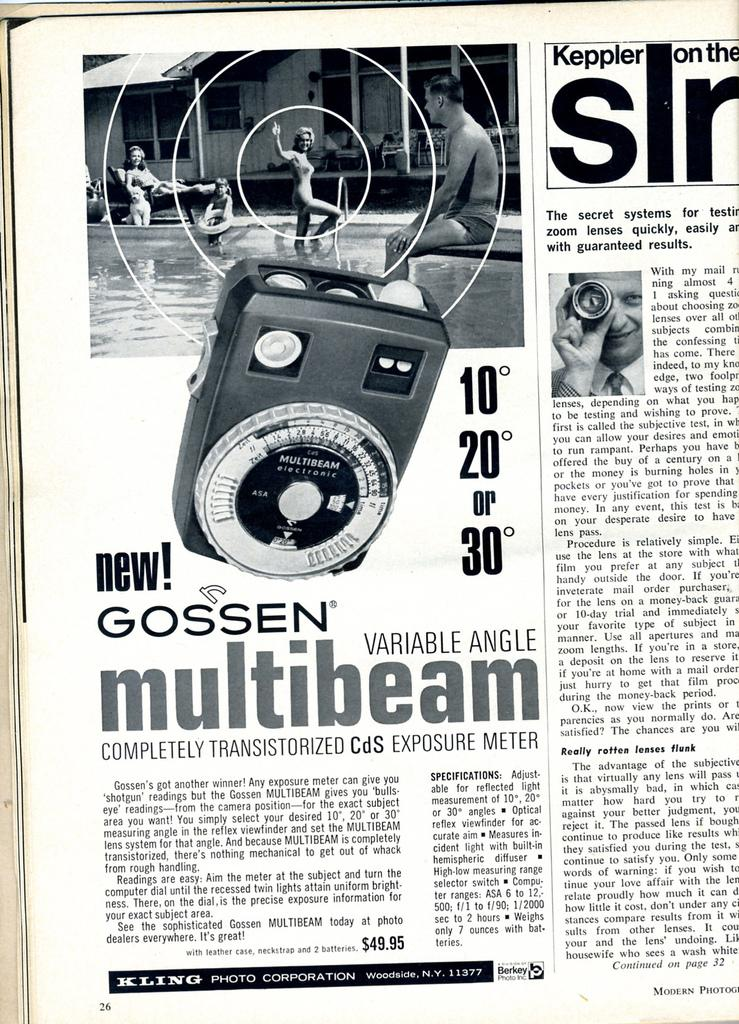What is the main subject in the foreground of the poster? There is a newspaper page in the foreground of the poster. What type of content can be found on the newspaper pages? The newspaper page contains text and images. Can you describe a specific image on the newspaper page? There is an image of a meter device on the newspaper page. Are there any snails visible on the newspaper page? There are no snails visible on the newspaper page; the image only contains text and an image of a meter device. 